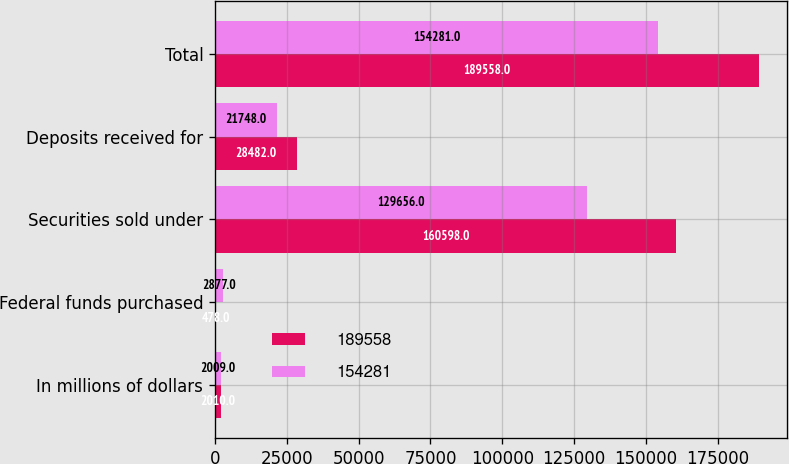Convert chart to OTSL. <chart><loc_0><loc_0><loc_500><loc_500><stacked_bar_chart><ecel><fcel>In millions of dollars<fcel>Federal funds purchased<fcel>Securities sold under<fcel>Deposits received for<fcel>Total<nl><fcel>189558<fcel>2010<fcel>478<fcel>160598<fcel>28482<fcel>189558<nl><fcel>154281<fcel>2009<fcel>2877<fcel>129656<fcel>21748<fcel>154281<nl></chart> 